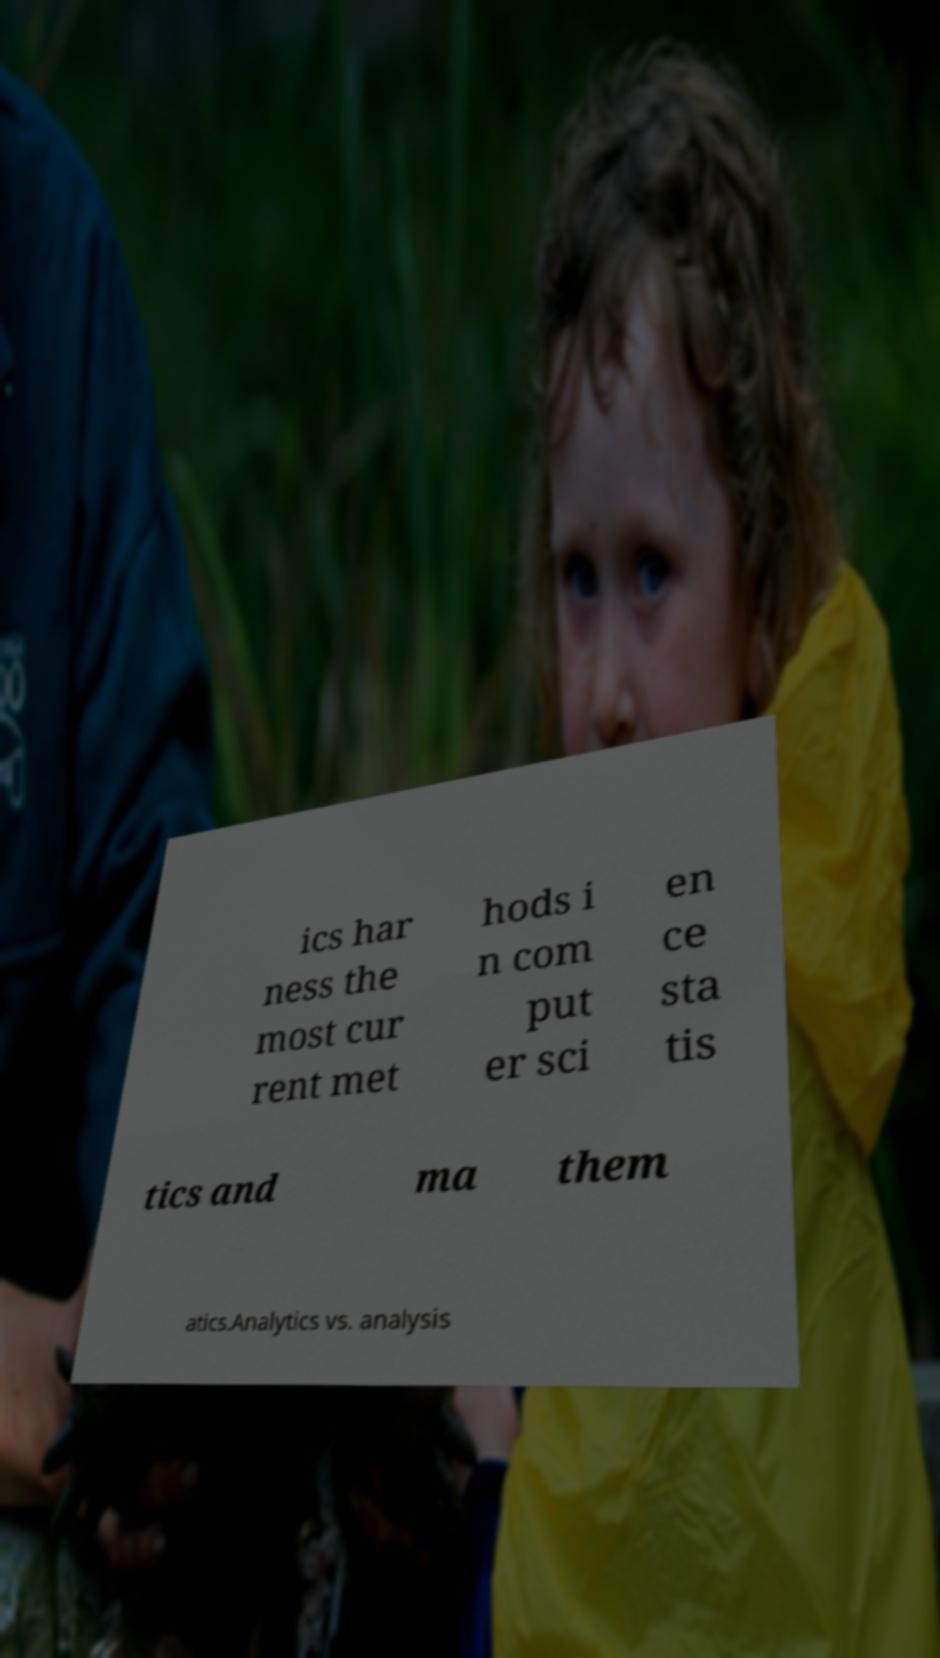There's text embedded in this image that I need extracted. Can you transcribe it verbatim? ics har ness the most cur rent met hods i n com put er sci en ce sta tis tics and ma them atics.Analytics vs. analysis 